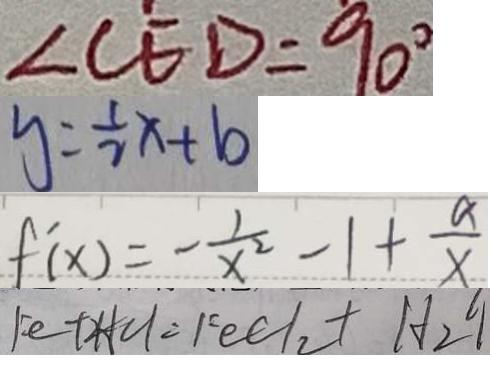<formula> <loc_0><loc_0><loc_500><loc_500>\angle C E D = 9 0 ^ { \circ } 
 y = \frac { 1 } { 2 } x + b 
 f ^ { \prime } ( x ) = - \frac { 1 } { x ^ { 2 } } - 1 + \frac { a } { x } 
 F e + 2 H C l = F e C l _ { 2 } + H _ { 2 } \uparrow</formula> 